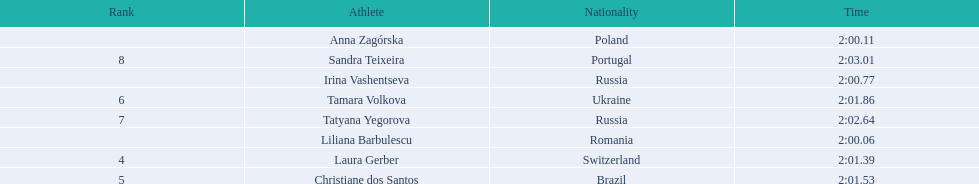Who were the athlete were in the athletics at the 2003 summer universiade - women's 800 metres? , Liliana Barbulescu, Anna Zagórska, Irina Vashentseva, Laura Gerber, Christiane dos Santos, Tamara Volkova, Tatyana Yegorova, Sandra Teixeira. What was anna zagorska finishing time? 2:00.11. 